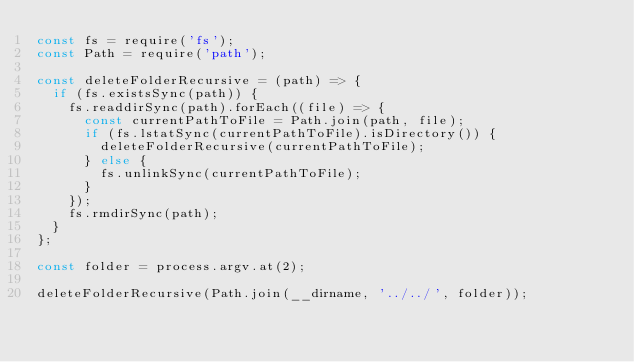Convert code to text. <code><loc_0><loc_0><loc_500><loc_500><_JavaScript_>const fs = require('fs');
const Path = require('path');

const deleteFolderRecursive = (path) => {
  if (fs.existsSync(path)) {
    fs.readdirSync(path).forEach((file) => {
      const currentPathToFile = Path.join(path, file);
      if (fs.lstatSync(currentPathToFile).isDirectory()) {
        deleteFolderRecursive(currentPathToFile);
      } else {
        fs.unlinkSync(currentPathToFile);
      }
    });
    fs.rmdirSync(path);
  }
};

const folder = process.argv.at(2);

deleteFolderRecursive(Path.join(__dirname, '../../', folder));
</code> 